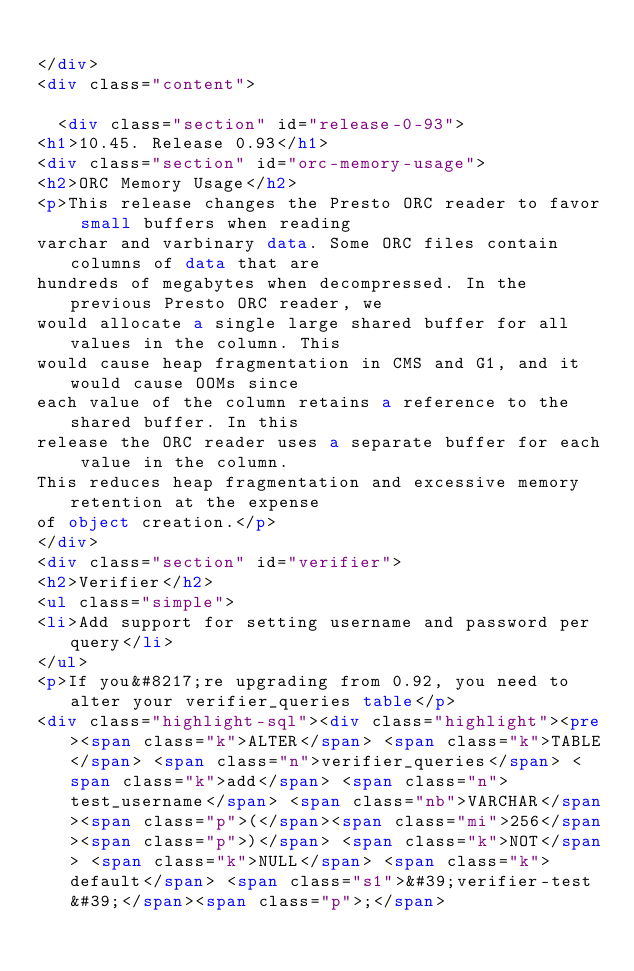<code> <loc_0><loc_0><loc_500><loc_500><_HTML_>
</div>
<div class="content">
    
  <div class="section" id="release-0-93">
<h1>10.45. Release 0.93</h1>
<div class="section" id="orc-memory-usage">
<h2>ORC Memory Usage</h2>
<p>This release changes the Presto ORC reader to favor small buffers when reading
varchar and varbinary data. Some ORC files contain columns of data that are
hundreds of megabytes when decompressed. In the previous Presto ORC reader, we
would allocate a single large shared buffer for all values in the column. This
would cause heap fragmentation in CMS and G1, and it would cause OOMs since
each value of the column retains a reference to the shared buffer. In this
release the ORC reader uses a separate buffer for each value in the column.
This reduces heap fragmentation and excessive memory retention at the expense
of object creation.</p>
</div>
<div class="section" id="verifier">
<h2>Verifier</h2>
<ul class="simple">
<li>Add support for setting username and password per query</li>
</ul>
<p>If you&#8217;re upgrading from 0.92, you need to alter your verifier_queries table</p>
<div class="highlight-sql"><div class="highlight"><pre><span class="k">ALTER</span> <span class="k">TABLE</span> <span class="n">verifier_queries</span> <span class="k">add</span> <span class="n">test_username</span> <span class="nb">VARCHAR</span><span class="p">(</span><span class="mi">256</span><span class="p">)</span> <span class="k">NOT</span> <span class="k">NULL</span> <span class="k">default</span> <span class="s1">&#39;verifier-test&#39;</span><span class="p">;</span></code> 